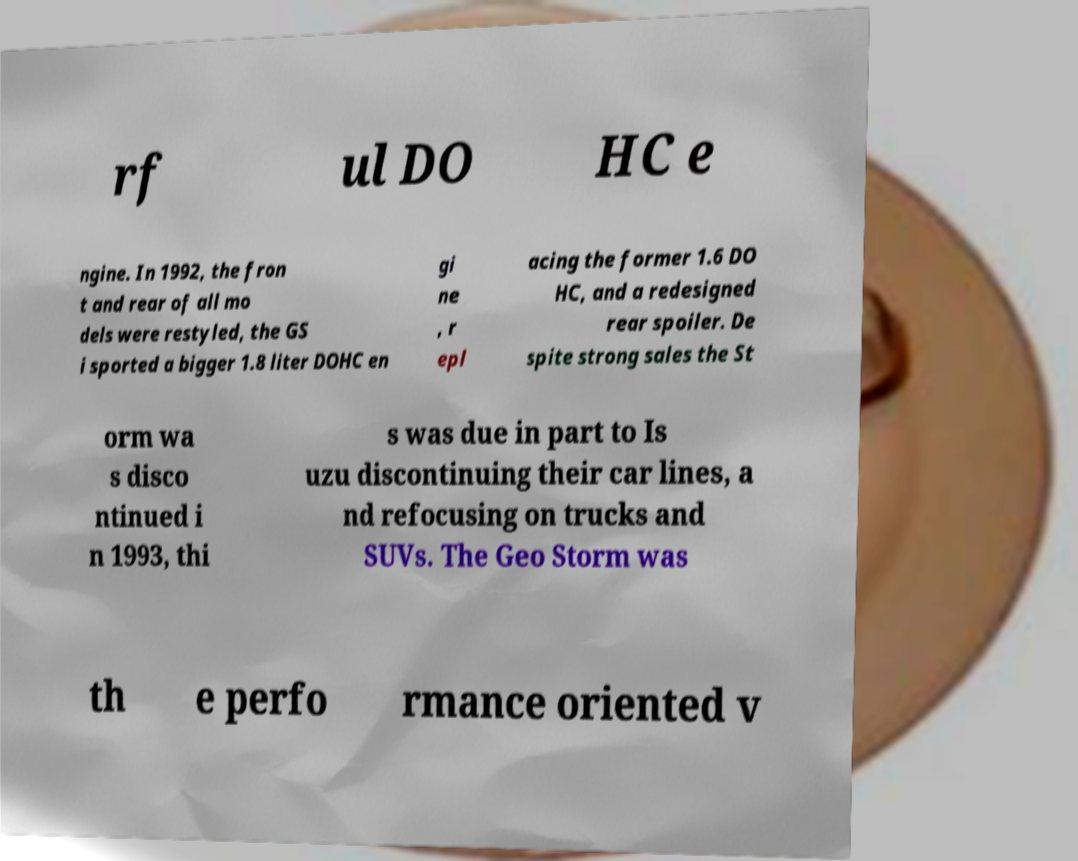Please identify and transcribe the text found in this image. rf ul DO HC e ngine. In 1992, the fron t and rear of all mo dels were restyled, the GS i sported a bigger 1.8 liter DOHC en gi ne , r epl acing the former 1.6 DO HC, and a redesigned rear spoiler. De spite strong sales the St orm wa s disco ntinued i n 1993, thi s was due in part to Is uzu discontinuing their car lines, a nd refocusing on trucks and SUVs. The Geo Storm was th e perfo rmance oriented v 